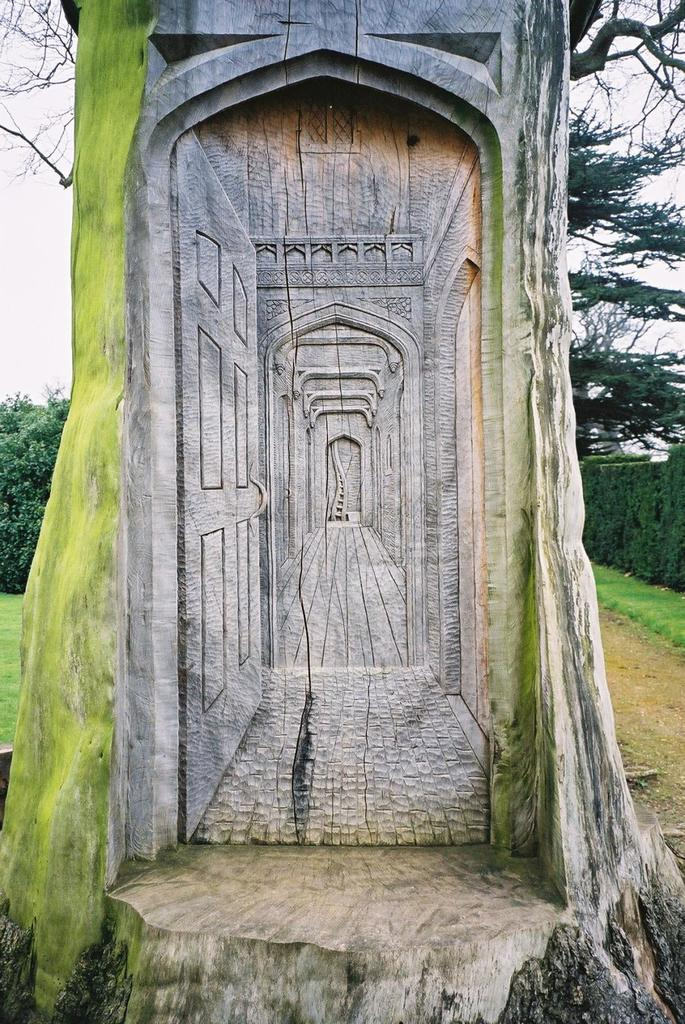What is the main feature of the tree in the foreground? There is a 3D design on the trunk of the tree in the foreground. What can be seen in the background of the image? There are trees and land visible in the background, as well as the sky. What degree of difficulty is the 3D design on the tree trunk? The degree of difficulty of the 3D design on the tree trunk cannot be determined from the image. How many parcels of land are visible in the background? There is no mention of parcels of land in the image; only land in general is visible. 